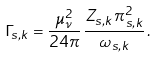<formula> <loc_0><loc_0><loc_500><loc_500>\Gamma _ { s , k } = \frac { \mu _ { \nu } ^ { 2 } } { 2 4 \pi } \, \frac { Z _ { s , k } \, \pi _ { s , k } ^ { 2 } } { \omega _ { s , k } } \, .</formula> 